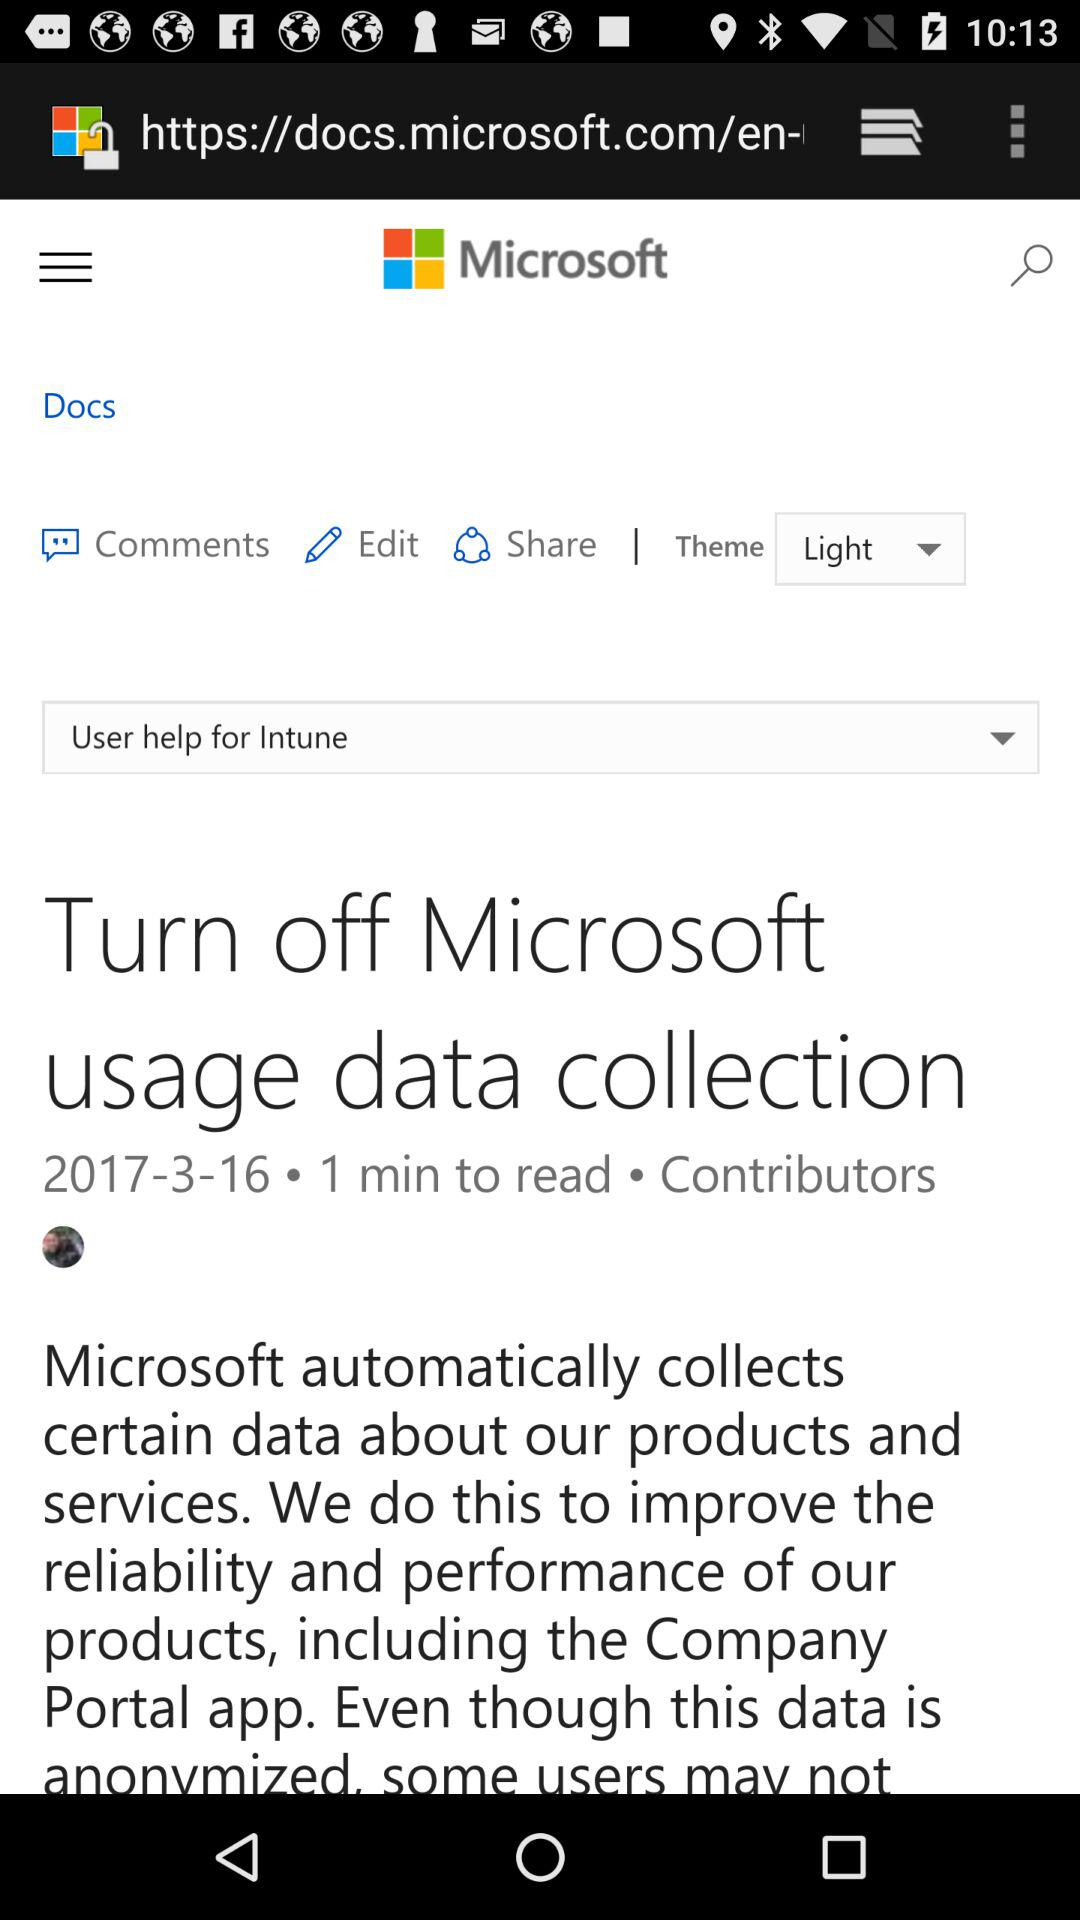What is the name of the application? The name of the application is "Microsoft". 